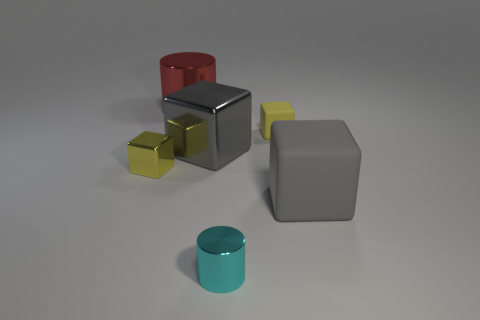Does the big object in front of the yellow metal object have the same shape as the small yellow rubber thing?
Keep it short and to the point. Yes. How many big rubber blocks are there?
Keep it short and to the point. 1. How many other yellow metallic cubes are the same size as the yellow metal block?
Keep it short and to the point. 0. What is the material of the big red cylinder?
Your answer should be very brief. Metal. There is a big matte block; does it have the same color as the tiny cube that is on the left side of the tiny cyan shiny object?
Your answer should be very brief. No. Is there anything else that has the same size as the cyan object?
Give a very brief answer. Yes. What size is the metal thing that is both to the left of the cyan cylinder and right of the big metallic cylinder?
Your answer should be very brief. Large. There is a gray thing that is the same material as the cyan object; what shape is it?
Provide a short and direct response. Cube. Is the small cyan cylinder made of the same material as the tiny block left of the gray shiny object?
Make the answer very short. Yes. Are there any things in front of the tiny yellow cube right of the red metal thing?
Make the answer very short. Yes. 